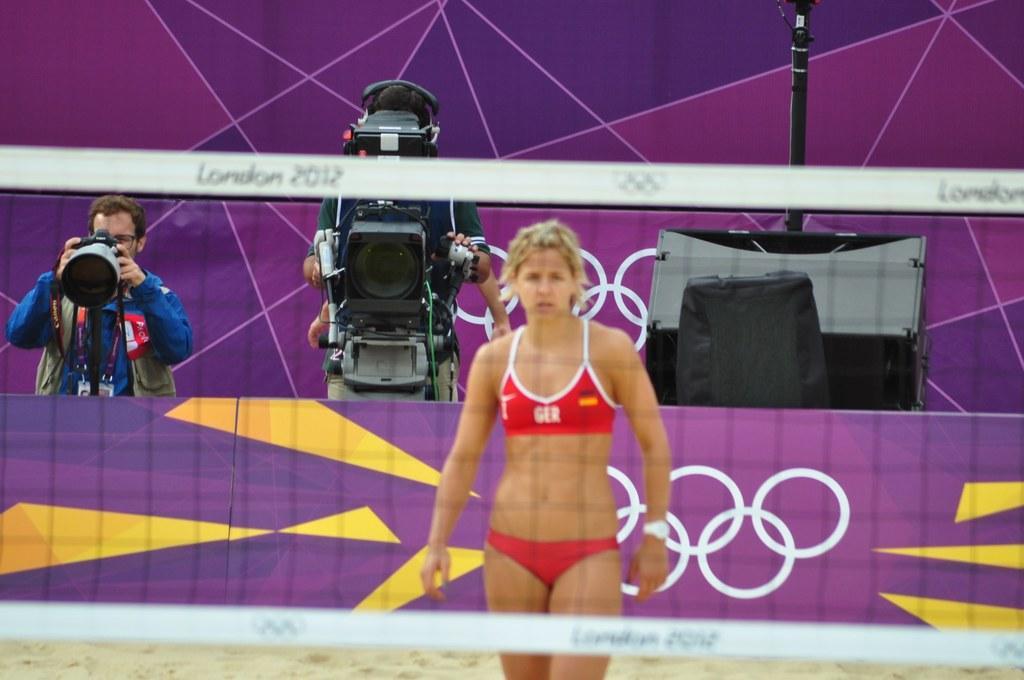Please provide a concise description of this image. In this image I can see three people are standing and two of them are holding cameras. 